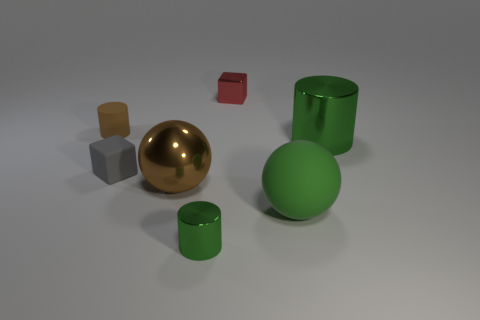What number of rubber objects are large brown balls or purple balls?
Give a very brief answer. 0. How many rubber things are in front of the small matte block and to the left of the metallic cube?
Your answer should be very brief. 0. What number of other objects are the same size as the gray matte block?
Your answer should be very brief. 3. Does the green metal cylinder that is in front of the tiny gray thing have the same size as the brown rubber cylinder that is to the left of the green matte object?
Give a very brief answer. Yes. What number of things are either red objects or tiny red metal things that are behind the green matte object?
Your answer should be very brief. 1. What size is the green metallic thing on the left side of the tiny red shiny thing?
Make the answer very short. Small. Are there fewer large green rubber spheres to the left of the rubber cylinder than spheres that are to the right of the small red cube?
Provide a succinct answer. Yes. What material is the cylinder that is both on the left side of the big cylinder and behind the tiny gray thing?
Keep it short and to the point. Rubber. What is the shape of the large object that is left of the small cube that is behind the small brown object?
Your answer should be compact. Sphere. Is the tiny shiny cylinder the same color as the large cylinder?
Ensure brevity in your answer.  Yes. 